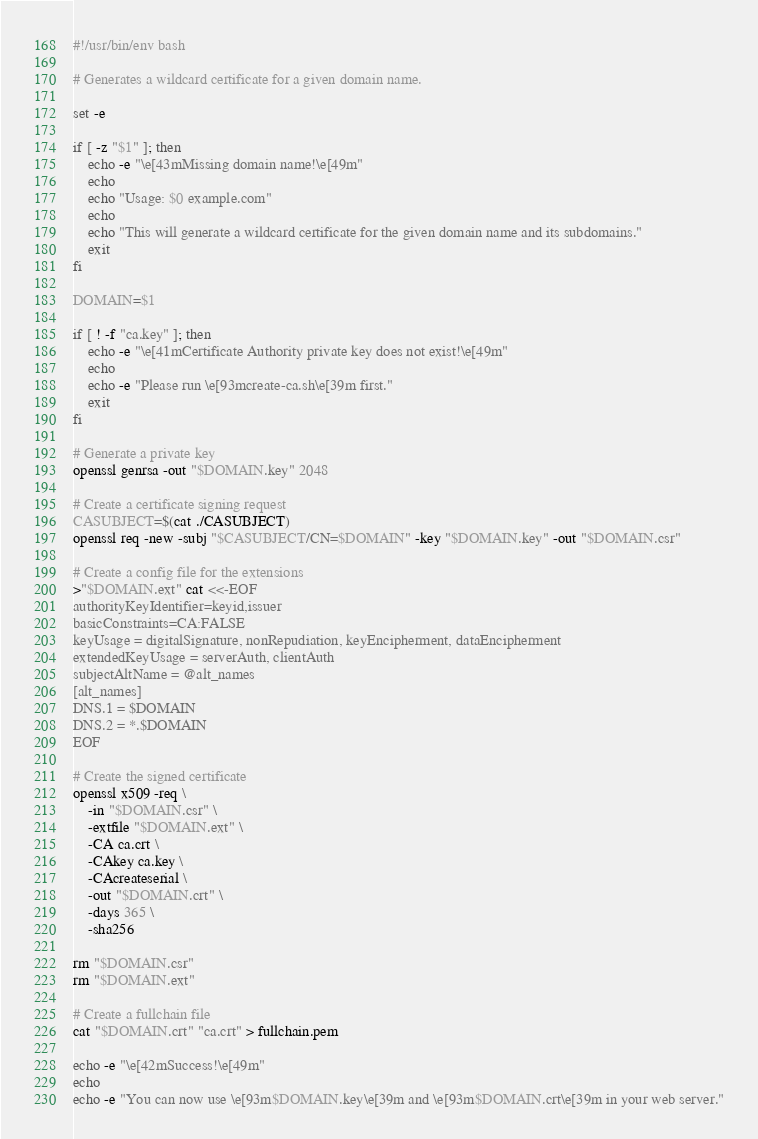Convert code to text. <code><loc_0><loc_0><loc_500><loc_500><_Bash_>#!/usr/bin/env bash

# Generates a wildcard certificate for a given domain name.

set -e

if [ -z "$1" ]; then
    echo -e "\e[43mMissing domain name!\e[49m"
    echo
    echo "Usage: $0 example.com"
    echo
    echo "This will generate a wildcard certificate for the given domain name and its subdomains."
    exit
fi

DOMAIN=$1

if [ ! -f "ca.key" ]; then
    echo -e "\e[41mCertificate Authority private key does not exist!\e[49m"
    echo
    echo -e "Please run \e[93mcreate-ca.sh\e[39m first."
    exit
fi

# Generate a private key
openssl genrsa -out "$DOMAIN.key" 2048

# Create a certificate signing request
CASUBJECT=$(cat ./CASUBJECT)
openssl req -new -subj "$CASUBJECT/CN=$DOMAIN" -key "$DOMAIN.key" -out "$DOMAIN.csr"

# Create a config file for the extensions
>"$DOMAIN.ext" cat <<-EOF
authorityKeyIdentifier=keyid,issuer
basicConstraints=CA:FALSE
keyUsage = digitalSignature, nonRepudiation, keyEncipherment, dataEncipherment
extendedKeyUsage = serverAuth, clientAuth
subjectAltName = @alt_names
[alt_names]
DNS.1 = $DOMAIN
DNS.2 = *.$DOMAIN
EOF

# Create the signed certificate
openssl x509 -req \
    -in "$DOMAIN.csr" \
    -extfile "$DOMAIN.ext" \
    -CA ca.crt \
    -CAkey ca.key \
    -CAcreateserial \
    -out "$DOMAIN.crt" \
    -days 365 \
    -sha256

rm "$DOMAIN.csr"
rm "$DOMAIN.ext"

# Create a fullchain file
cat "$DOMAIN.crt" "ca.crt" > fullchain.pem

echo -e "\e[42mSuccess!\e[49m"
echo
echo -e "You can now use \e[93m$DOMAIN.key\e[39m and \e[93m$DOMAIN.crt\e[39m in your web server."</code> 